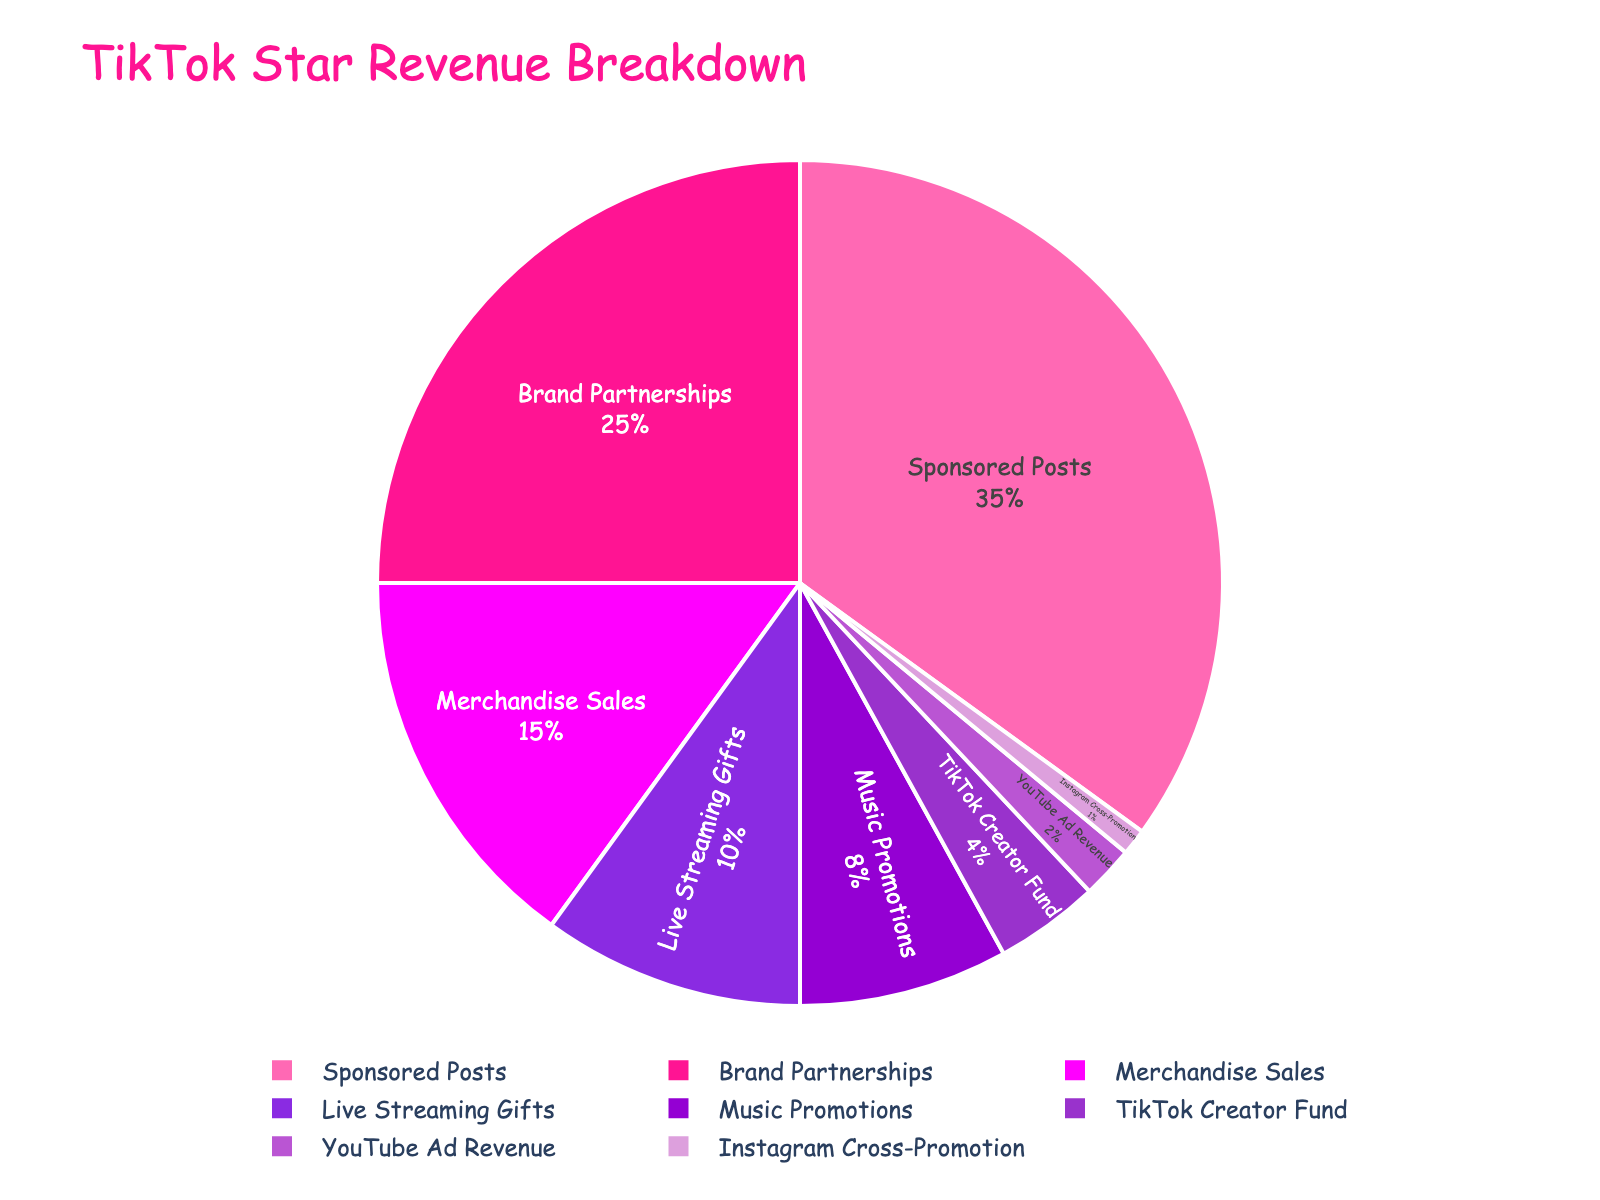What percentage of revenue comes from Sponsored Posts? Sponsored Posts make up the biggest slice of the pie chart, and the label on this section shows that it represents 35% of the total revenue.
Answer: 35% Which revenue source contributes less, TikTok Creator Fund or Instagram Cross-Promotion? Instagram Cross-Promotion has a smaller slice in the pie chart compared to TikTok Creator Fund. The labels indicate that TikTok Creator Fund is 4%, while Instagram Cross-Promotion is 1%.
Answer: Instagram Cross-Promotion What is the combined percentage of Merchandise Sales and Live Streaming Gifts? Merchandise Sales is 15%, and Live Streaming Gifts is 10%. Adding these two percentages together, we get 15% + 10% = 25%.
Answer: 25% How much greater is the revenue percentage from Sponsored Posts compared to Music Promotions? Sponsored Posts contributes 35% while Music Promotions contributes 8%. The difference is 35% - 8% = 27%.
Answer: 27% Which revenue source has the second-largest percentage? From the pie chart, the second-largest slice after Sponsored Posts (35%) is Brand Partnerships, which is labeled as 25%.
Answer: Brand Partnerships What is the total percentage of revenue sources that contribute less than 10%? Adding the percentages of revenue sources less than 10%: Live Streaming Gifts (10%), Music Promotions (8%), TikTok Creator Fund (4%), YouTube Ad Revenue (2%), Instagram Cross-Promotion (1%). 10% + 8% + 4% + 2% + 1% = 25%.
Answer: 25% How does the percentage of YouTube Ad Revenue compare to TikTok Creator Fund? YouTube Ad Revenue is represented by 2%, whereas TikTok Creator Fund is represented by 4% in the pie chart. 2% is less than 4%.
Answer: less What is the most visually striking attribute of the Sponsored Posts slice? The pie chart's Sponsored Posts slice is the largest section and is colored in a bright pink shade which stands out.
Answer: Large size and bright pink color 